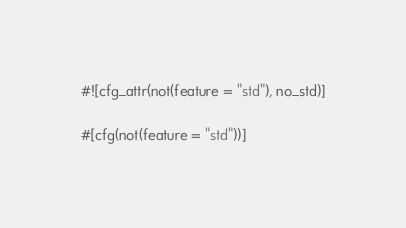<code> <loc_0><loc_0><loc_500><loc_500><_Rust_>#![cfg_attr(not(feature = "std"), no_std)]

#[cfg(not(feature = "std"))]</code> 